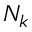Convert formula to latex. <formula><loc_0><loc_0><loc_500><loc_500>N _ { k }</formula> 